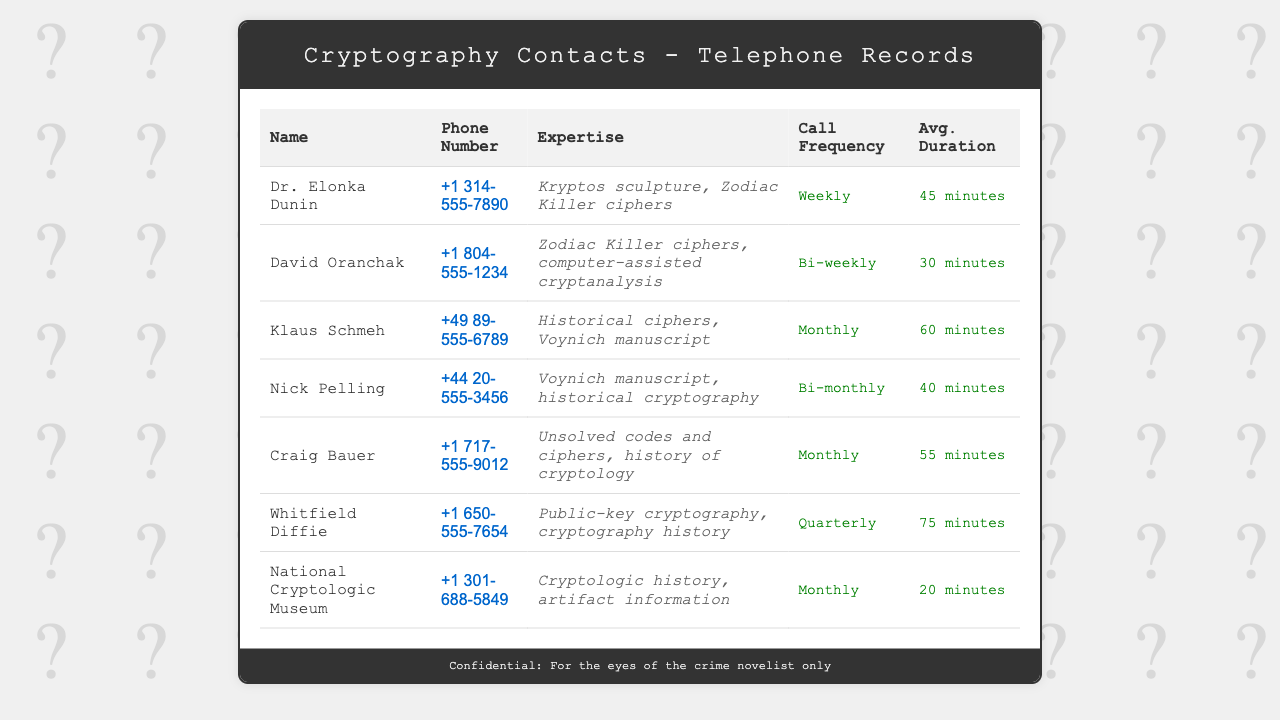What is the phone number of Dr. Elonka Dunin? The phone number can be found in the document under her details, which is +1 314-555-7890.
Answer: +1 314-555-7890 How often does Klaus Schmeh make calls? The call frequency for Klaus Schmeh is specified as "Monthly."
Answer: Monthly What expertise does David Oranchak have? The document lists his area of expertise as "Zodiac Killer ciphers, computer-assisted cryptanalysis."
Answer: Zodiac Killer ciphers, computer-assisted cryptanalysis Who has the highest average call duration? By comparing the average durations, it can be seen that Whitfield Diffie has the highest at 75 minutes.
Answer: 75 minutes What is the monthly call frequency for the National Cryptologic Museum? The frequency for the National Cryptologic Museum is indicated as "Monthly."
Answer: Monthly Which expert specializes in historical ciphers? The document identifies Klaus Schmeh as specializing in historical ciphers.
Answer: Klaus Schmeh How many experts have a call frequency of bi-monthly? There is only one individual listed with bi-monthly call frequency: Nick Pelling.
Answer: One What is the average duration of calls for Craig Bauer? The average duration for Craig Bauer's calls is stated as 55 minutes.
Answer: 55 minutes 